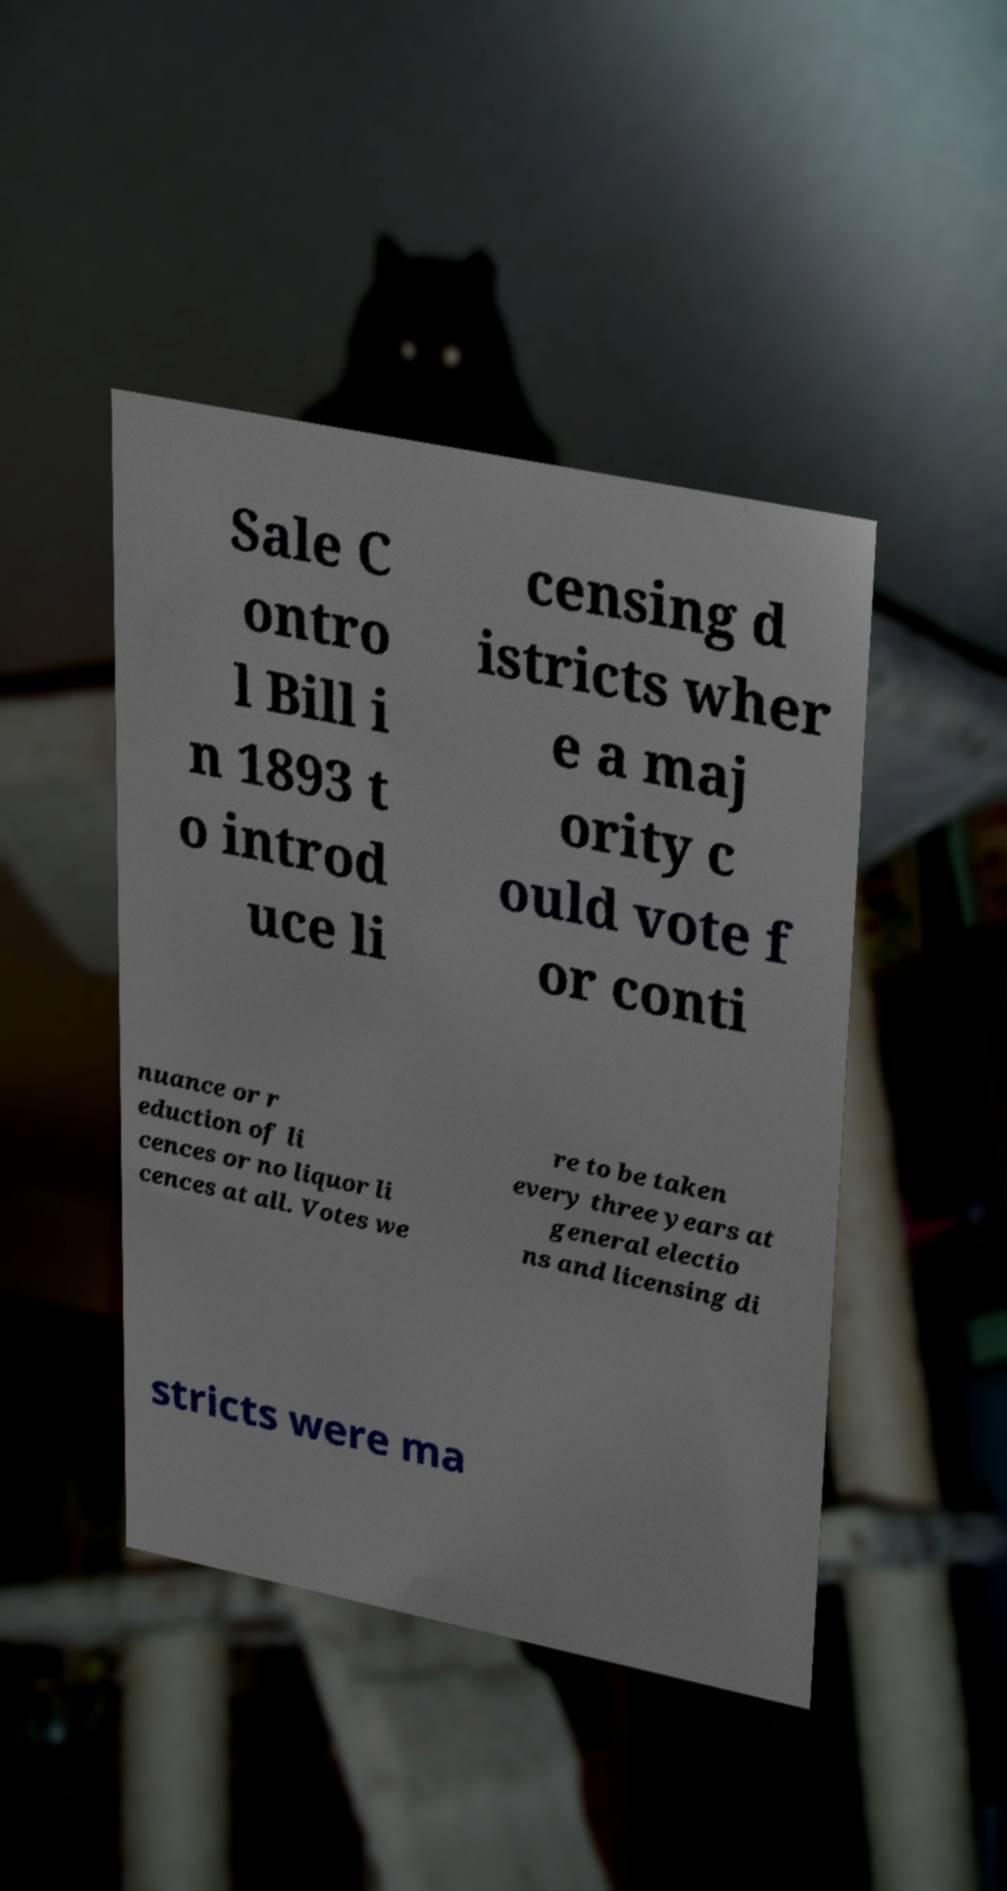What messages or text are displayed in this image? I need them in a readable, typed format. Sale C ontro l Bill i n 1893 t o introd uce li censing d istricts wher e a maj ority c ould vote f or conti nuance or r eduction of li cences or no liquor li cences at all. Votes we re to be taken every three years at general electio ns and licensing di stricts were ma 